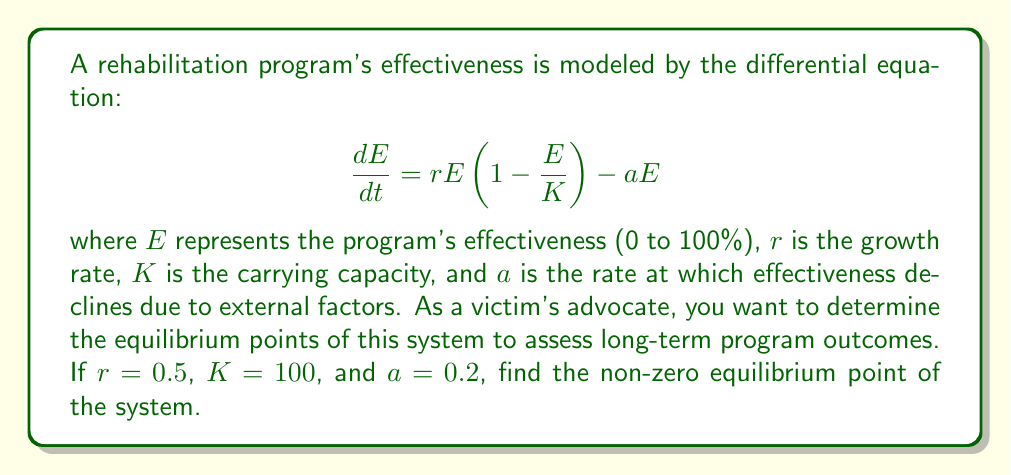Can you solve this math problem? To find the equilibrium points, we set the derivative equal to zero:

$$\frac{dE}{dt} = 0$$

Substituting the equation:

$$0 = rE(1 - \frac{E}{K}) - aE$$

Factoring out $E$:

$$0 = E(r(1 - \frac{E}{K}) - a)$$

There are two solutions:

1. $E = 0$ (trivial solution)
2. $r(1 - \frac{E}{K}) - a = 0$

We're interested in the non-zero solution, so we solve:

$$r(1 - \frac{E}{K}) - a = 0$$

$$r - \frac{rE}{K} = a$$

$$r - a = \frac{rE}{K}$$

$$E = \frac{K(r-a)}{r}$$

Now, substituting the given values:

$$E = \frac{100(0.5 - 0.2)}{0.5}$$

$$E = \frac{100(0.3)}{0.5} = 60$$

Therefore, the non-zero equilibrium point is 60%.
Answer: 60% 